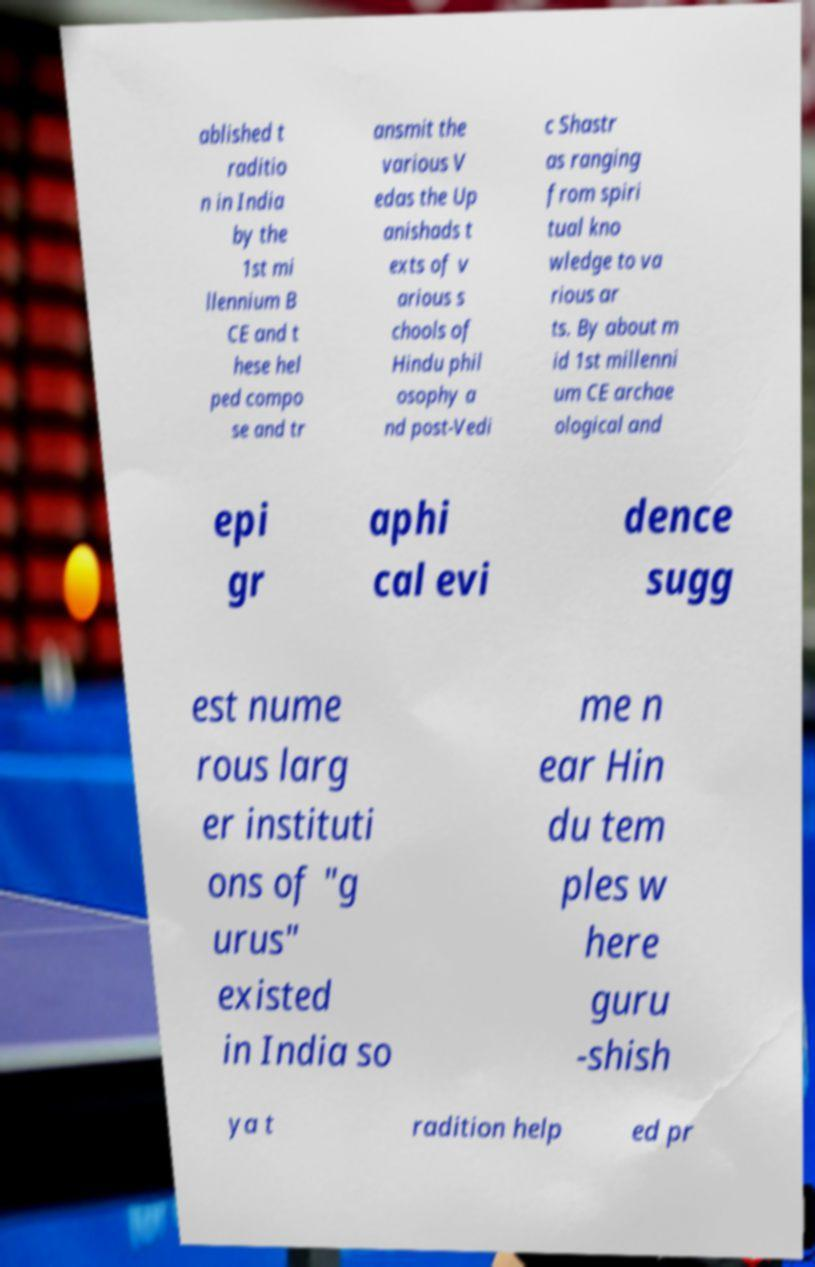I need the written content from this picture converted into text. Can you do that? ablished t raditio n in India by the 1st mi llennium B CE and t hese hel ped compo se and tr ansmit the various V edas the Up anishads t exts of v arious s chools of Hindu phil osophy a nd post-Vedi c Shastr as ranging from spiri tual kno wledge to va rious ar ts. By about m id 1st millenni um CE archae ological and epi gr aphi cal evi dence sugg est nume rous larg er instituti ons of "g urus" existed in India so me n ear Hin du tem ples w here guru -shish ya t radition help ed pr 